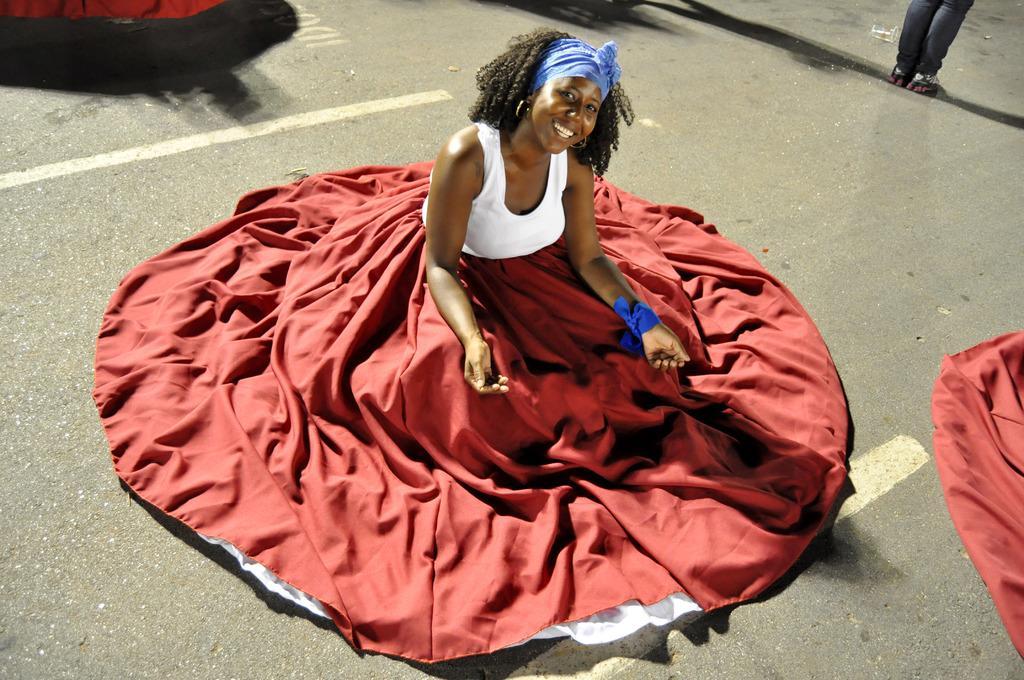How would you summarize this image in a sentence or two? In this image we can see a woman sitting and posing for a photo on the road and there are some other objects and we can see the person's legs. 